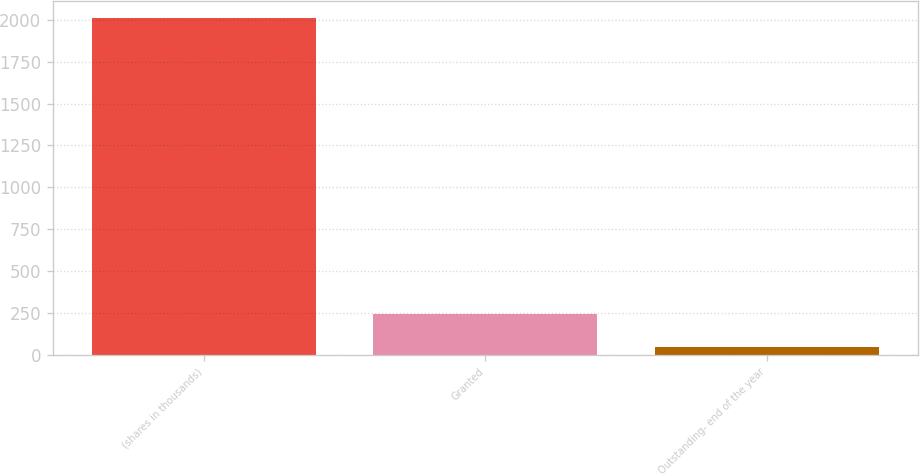<chart> <loc_0><loc_0><loc_500><loc_500><bar_chart><fcel>(shares in thousands)<fcel>Granted<fcel>Outstanding- end of the year<nl><fcel>2012<fcel>243.17<fcel>46.63<nl></chart> 